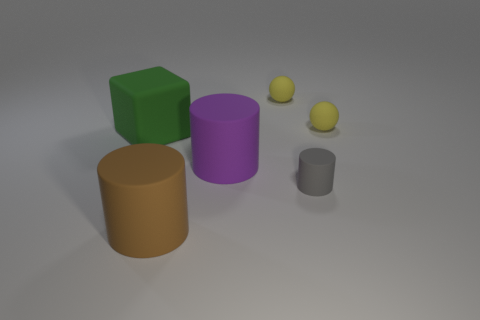The matte cube has what color?
Your response must be concise. Green. How many small gray matte objects are behind the tiny rubber thing that is in front of the green object?
Your response must be concise. 0. Are there any yellow rubber balls to the left of the small thing that is in front of the green thing?
Your response must be concise. Yes. There is a small gray thing; are there any small yellow balls on the left side of it?
Offer a very short reply. Yes. Does the big object on the right side of the big brown object have the same shape as the gray object?
Your response must be concise. Yes. What number of green metallic things are the same shape as the gray thing?
Your answer should be compact. 0. Is there a brown thing made of the same material as the gray cylinder?
Your answer should be compact. Yes. How big is the rubber cylinder that is on the left side of the purple thing?
Your answer should be very brief. Large. How many small things are either purple metal cylinders or brown cylinders?
Your response must be concise. 0. Is the number of green matte cubes less than the number of things?
Provide a succinct answer. Yes. 